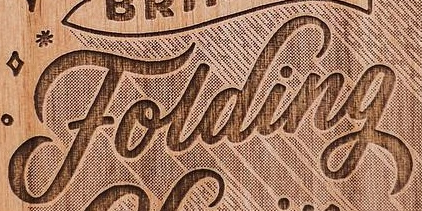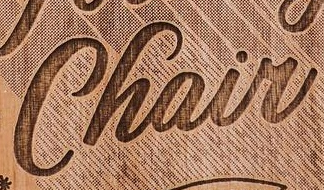Read the text from these images in sequence, separated by a semicolon. Folding; Chair 